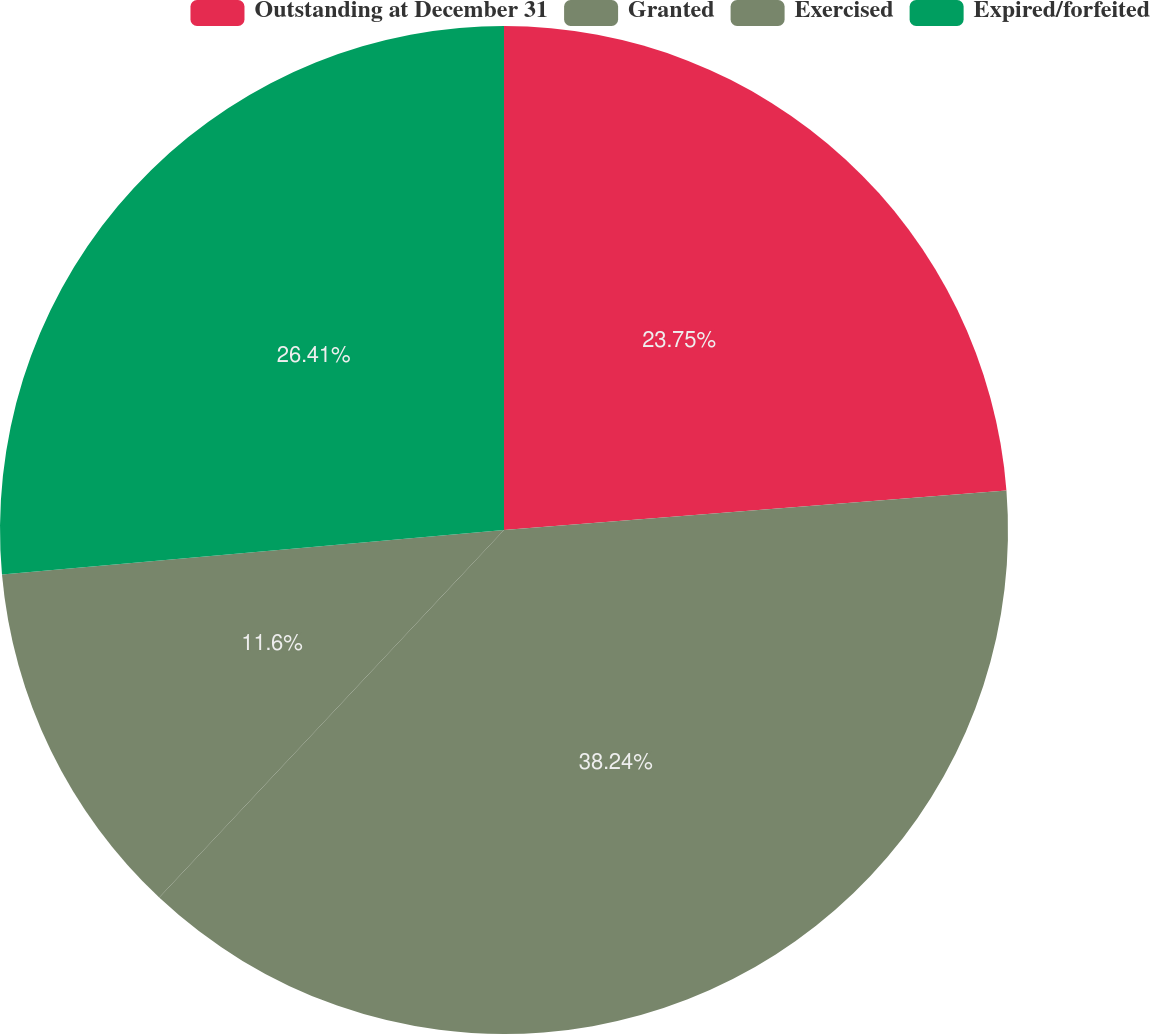Convert chart to OTSL. <chart><loc_0><loc_0><loc_500><loc_500><pie_chart><fcel>Outstanding at December 31<fcel>Granted<fcel>Exercised<fcel>Expired/forfeited<nl><fcel>23.75%<fcel>38.24%<fcel>11.6%<fcel>26.41%<nl></chart> 